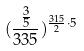Convert formula to latex. <formula><loc_0><loc_0><loc_500><loc_500>( \frac { \frac { 3 } { 5 } } { 3 3 5 } ) ^ { \frac { 3 1 5 } { 2 } \cdot 5 }</formula> 